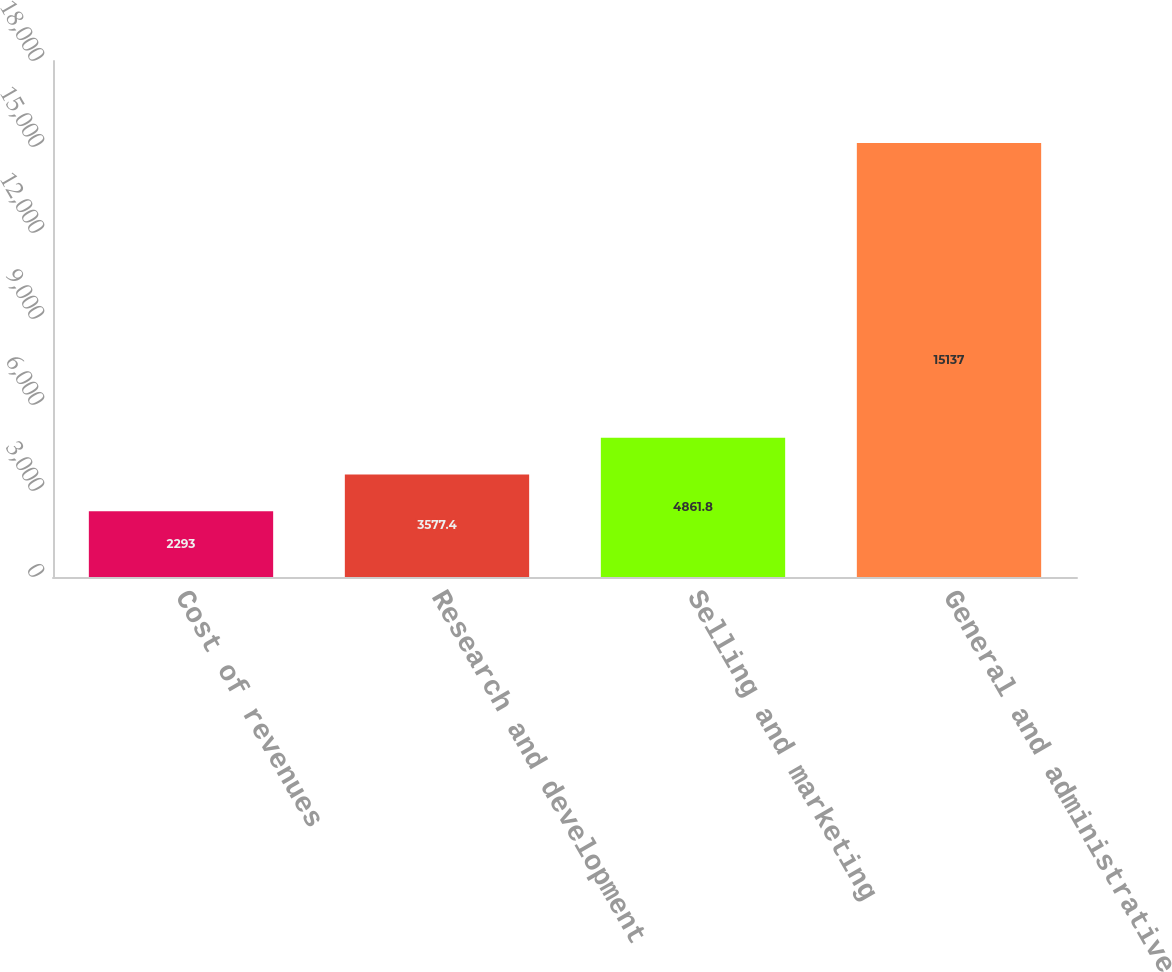<chart> <loc_0><loc_0><loc_500><loc_500><bar_chart><fcel>Cost of revenues<fcel>Research and development<fcel>Selling and marketing<fcel>General and administrative<nl><fcel>2293<fcel>3577.4<fcel>4861.8<fcel>15137<nl></chart> 